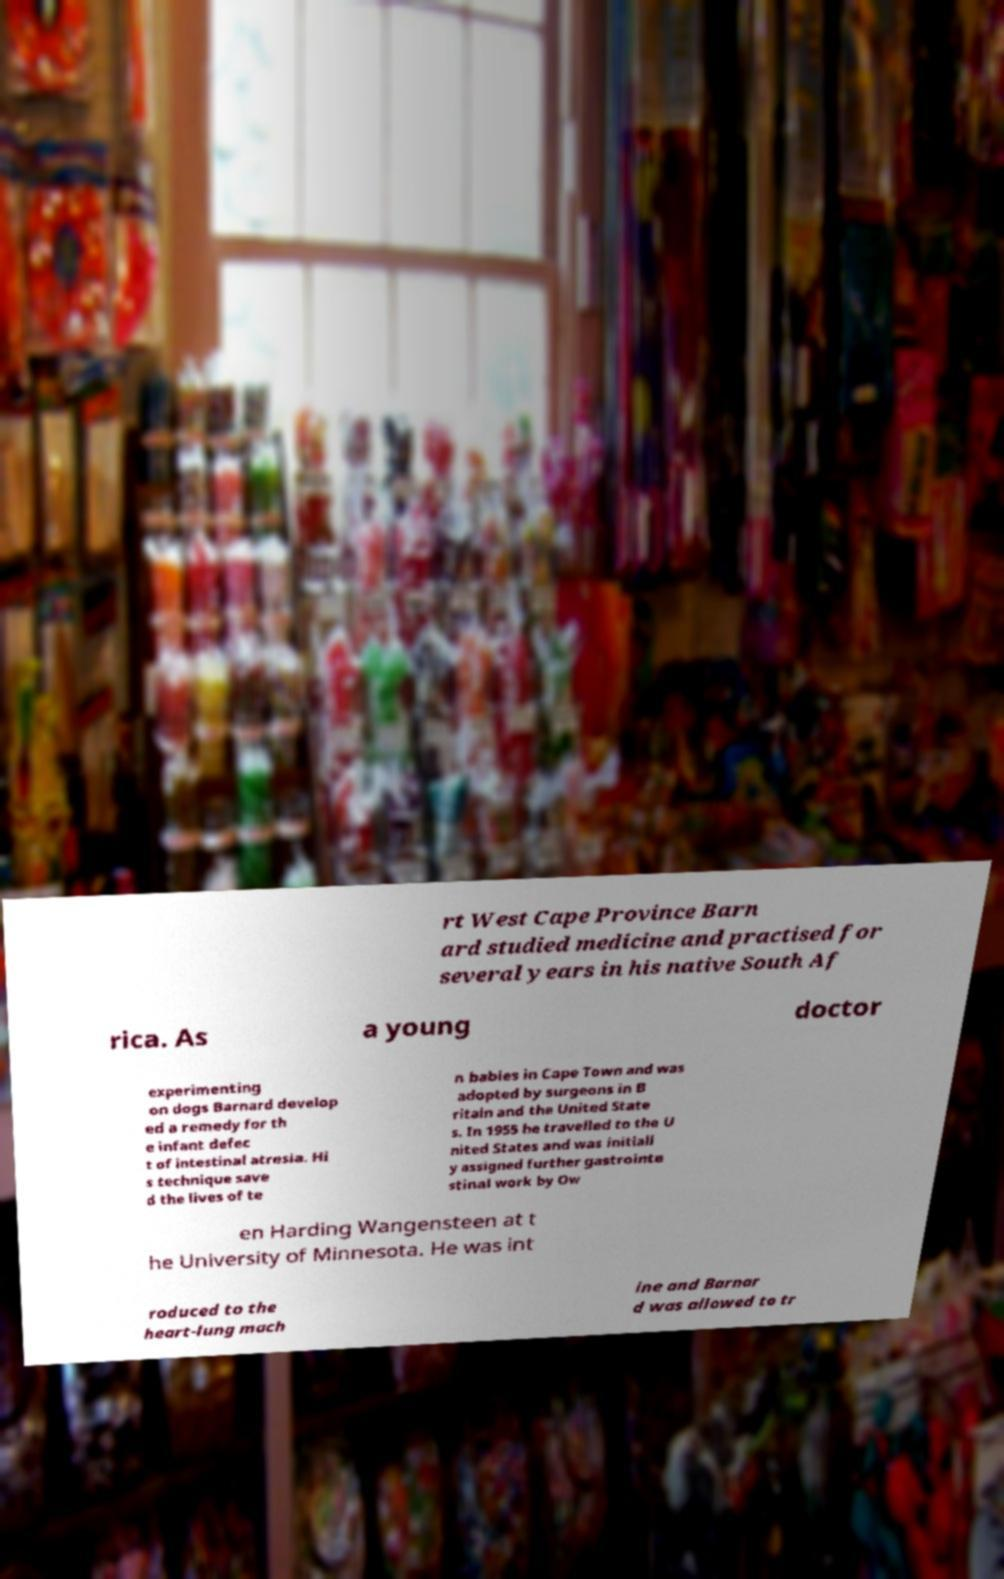For documentation purposes, I need the text within this image transcribed. Could you provide that? rt West Cape Province Barn ard studied medicine and practised for several years in his native South Af rica. As a young doctor experimenting on dogs Barnard develop ed a remedy for th e infant defec t of intestinal atresia. Hi s technique save d the lives of te n babies in Cape Town and was adopted by surgeons in B ritain and the United State s. In 1955 he travelled to the U nited States and was initiall y assigned further gastrointe stinal work by Ow en Harding Wangensteen at t he University of Minnesota. He was int roduced to the heart-lung mach ine and Barnar d was allowed to tr 